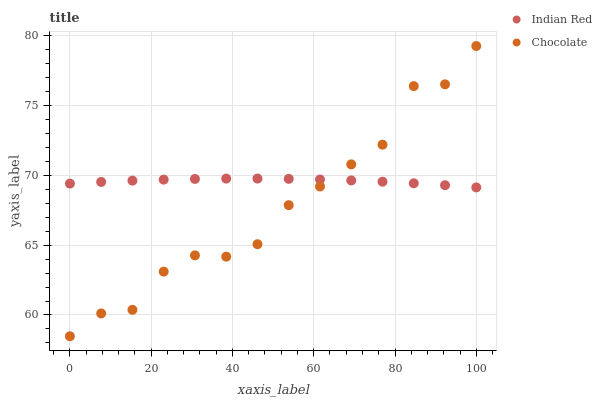Does Chocolate have the minimum area under the curve?
Answer yes or no. Yes. Does Indian Red have the maximum area under the curve?
Answer yes or no. Yes. Does Chocolate have the maximum area under the curve?
Answer yes or no. No. Is Indian Red the smoothest?
Answer yes or no. Yes. Is Chocolate the roughest?
Answer yes or no. Yes. Is Chocolate the smoothest?
Answer yes or no. No. Does Chocolate have the lowest value?
Answer yes or no. Yes. Does Chocolate have the highest value?
Answer yes or no. Yes. Does Indian Red intersect Chocolate?
Answer yes or no. Yes. Is Indian Red less than Chocolate?
Answer yes or no. No. Is Indian Red greater than Chocolate?
Answer yes or no. No. 